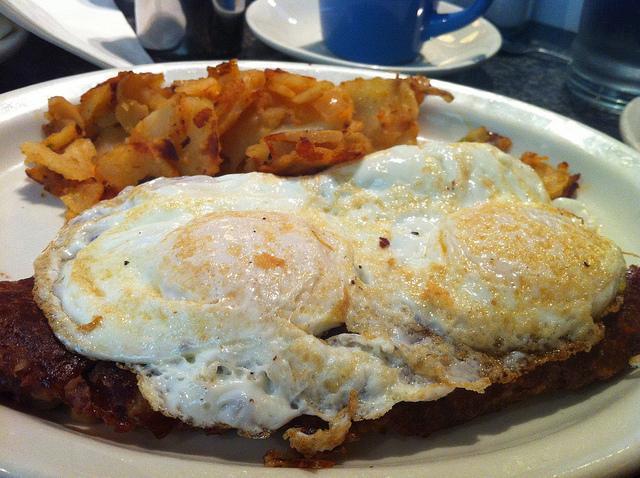How many cups are in the picture?
Give a very brief answer. 1. 